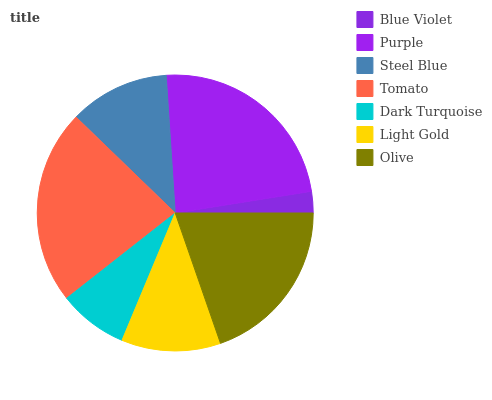Is Blue Violet the minimum?
Answer yes or no. Yes. Is Purple the maximum?
Answer yes or no. Yes. Is Steel Blue the minimum?
Answer yes or no. No. Is Steel Blue the maximum?
Answer yes or no. No. Is Purple greater than Steel Blue?
Answer yes or no. Yes. Is Steel Blue less than Purple?
Answer yes or no. Yes. Is Steel Blue greater than Purple?
Answer yes or no. No. Is Purple less than Steel Blue?
Answer yes or no. No. Is Steel Blue the high median?
Answer yes or no. Yes. Is Steel Blue the low median?
Answer yes or no. Yes. Is Dark Turquoise the high median?
Answer yes or no. No. Is Dark Turquoise the low median?
Answer yes or no. No. 